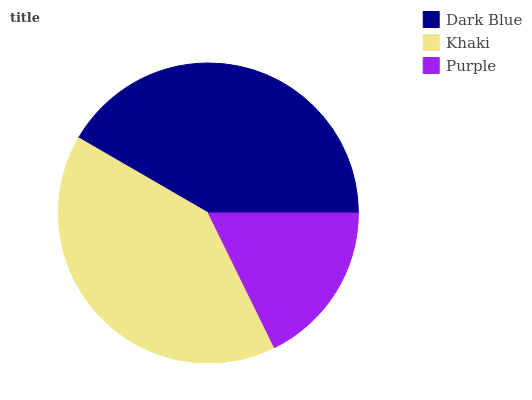Is Purple the minimum?
Answer yes or no. Yes. Is Dark Blue the maximum?
Answer yes or no. Yes. Is Khaki the minimum?
Answer yes or no. No. Is Khaki the maximum?
Answer yes or no. No. Is Dark Blue greater than Khaki?
Answer yes or no. Yes. Is Khaki less than Dark Blue?
Answer yes or no. Yes. Is Khaki greater than Dark Blue?
Answer yes or no. No. Is Dark Blue less than Khaki?
Answer yes or no. No. Is Khaki the high median?
Answer yes or no. Yes. Is Khaki the low median?
Answer yes or no. Yes. Is Purple the high median?
Answer yes or no. No. Is Purple the low median?
Answer yes or no. No. 